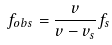<formula> <loc_0><loc_0><loc_500><loc_500>f _ { o b s } = \frac { v } { v - v _ { s } } f _ { s }</formula> 